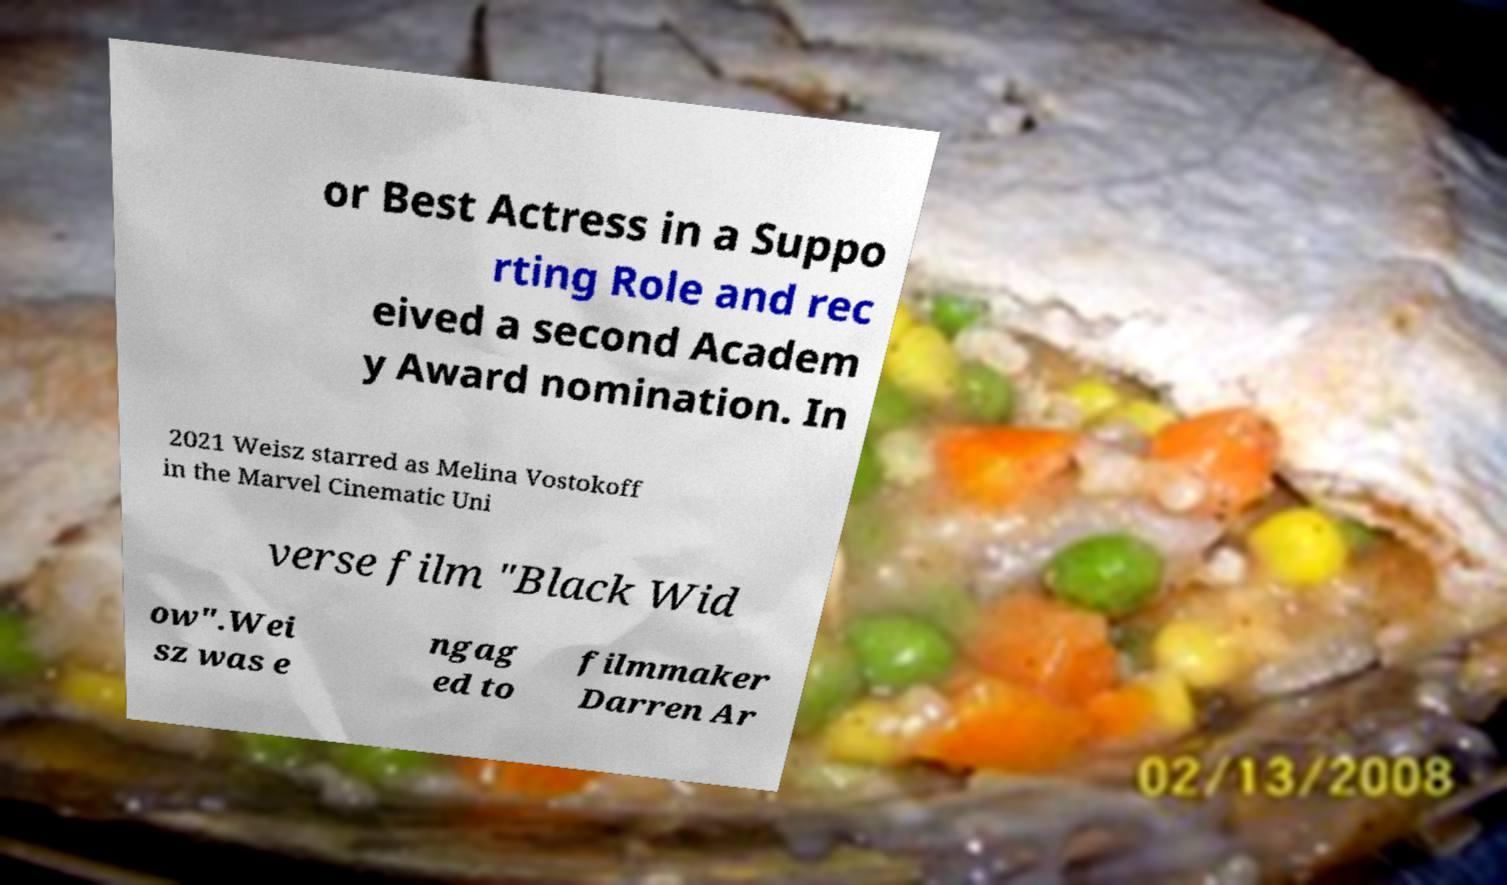There's text embedded in this image that I need extracted. Can you transcribe it verbatim? or Best Actress in a Suppo rting Role and rec eived a second Academ y Award nomination. In 2021 Weisz starred as Melina Vostokoff in the Marvel Cinematic Uni verse film "Black Wid ow".Wei sz was e ngag ed to filmmaker Darren Ar 